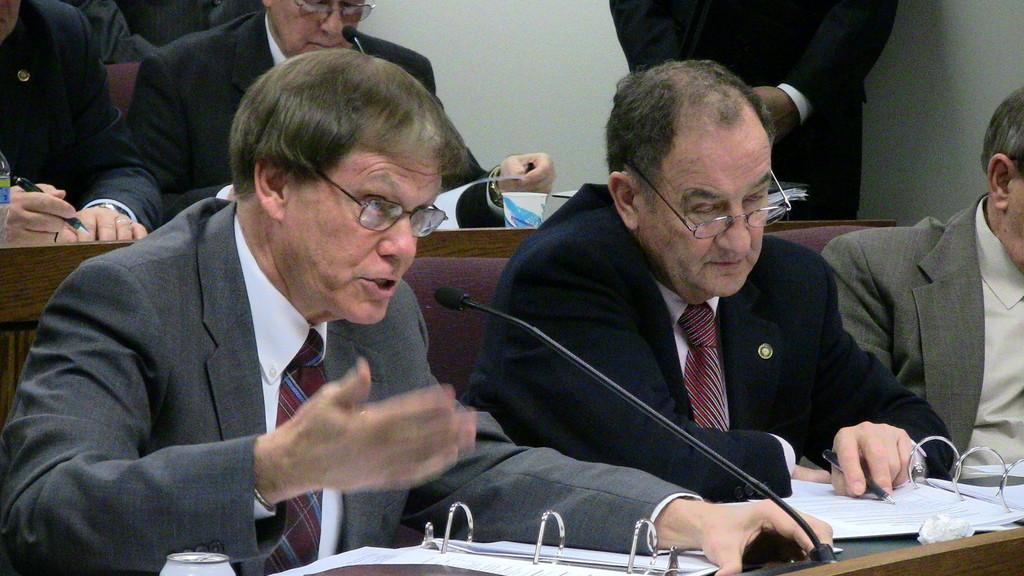Can you describe this image briefly? In this image we can see people sitting. They are wearing suits. There are tables and we can see books, mics, pens and papers placed on the tables. In the background there is a wall and we can see a man standing. 